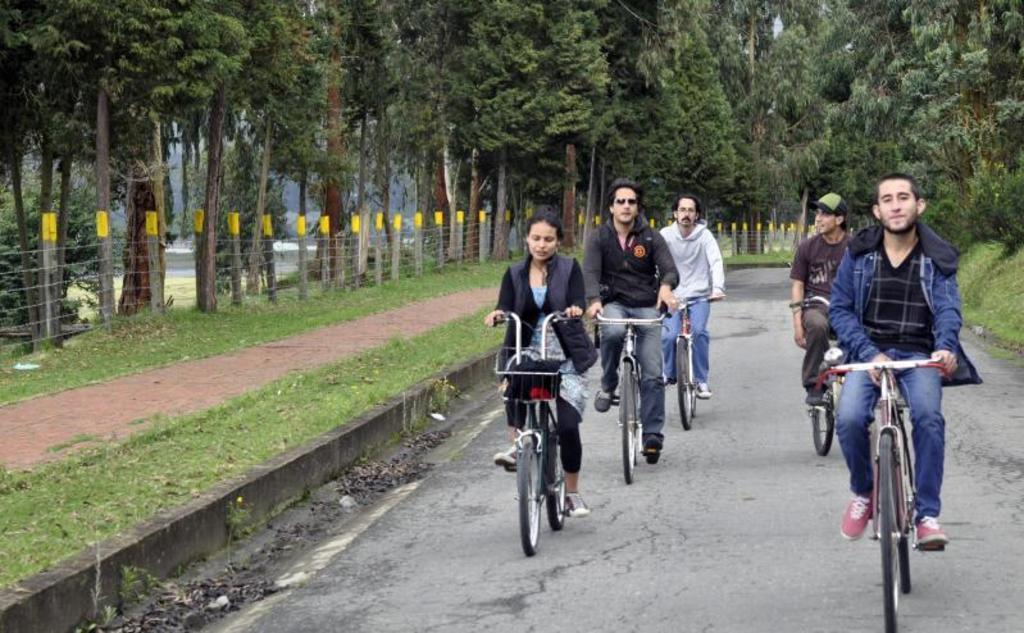Can you describe this image briefly? In this picture there are six persons who are riding the bicycle on the road. In the background I can see many trees, plants and grass. On the left I can see the concrete poles and steel wires are connected to it. in the back I can see the fencing. 